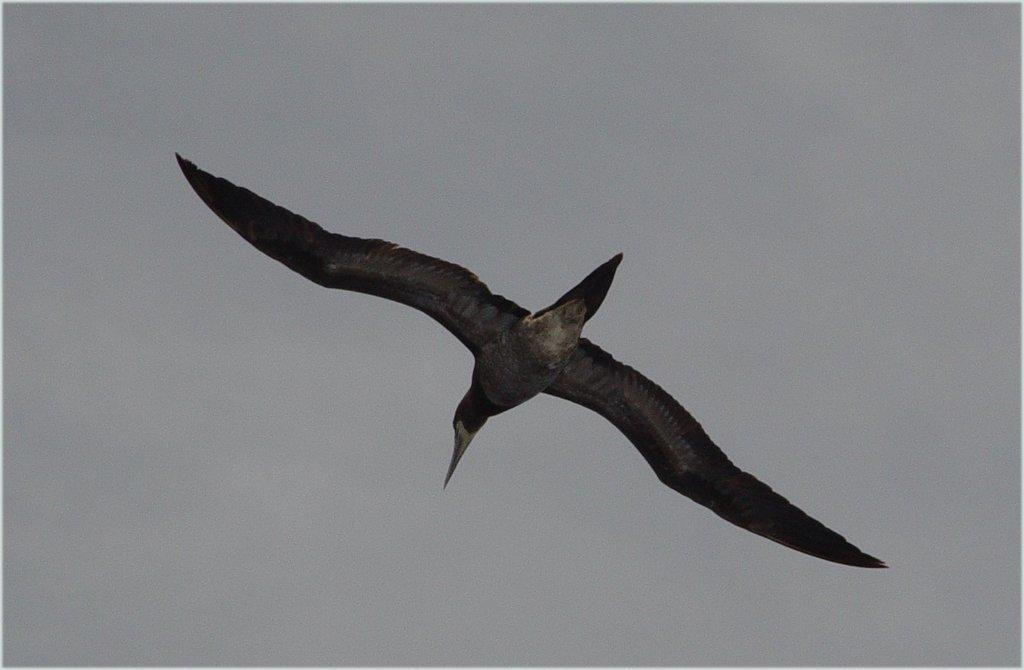What type of animal is present in the image? There is a bird in the image. What is the bird doing in the image? The bird is flying. What colors can be seen on the bird? The bird is white and black in color. How would you describe the sky in the image? The sky appears to be cloudy in the image. How many women are walking along the coast wearing suits in the image? There are no women, coast, or suits present in the image; it features a bird flying in a cloudy sky. 